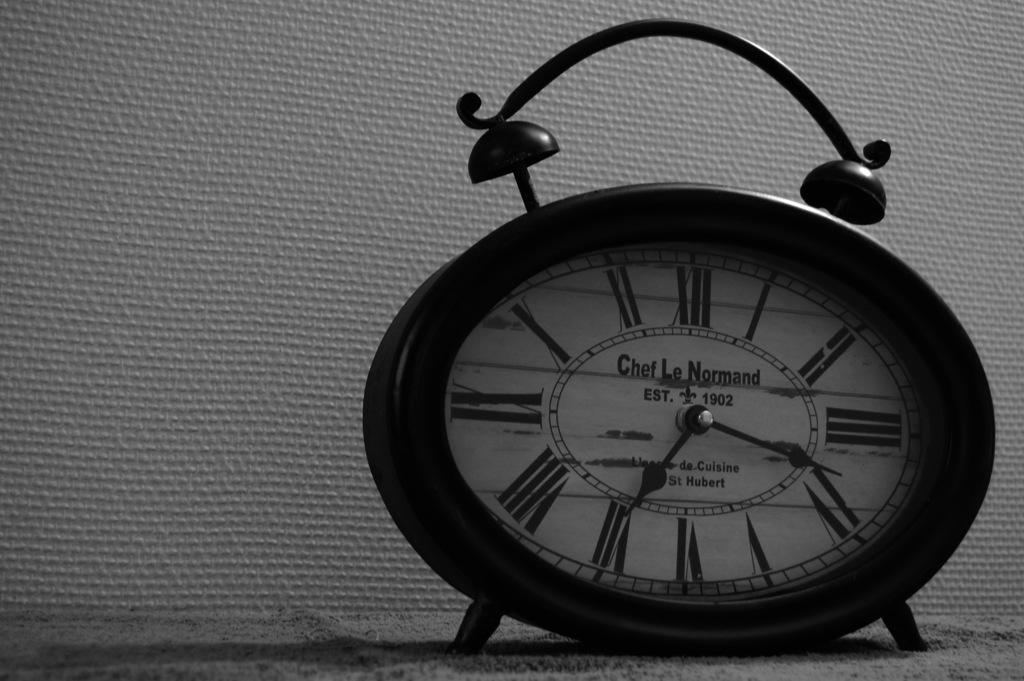<image>
Summarize the visual content of the image. A clock from the brand Chef Le Normand shows the time 7:17. 